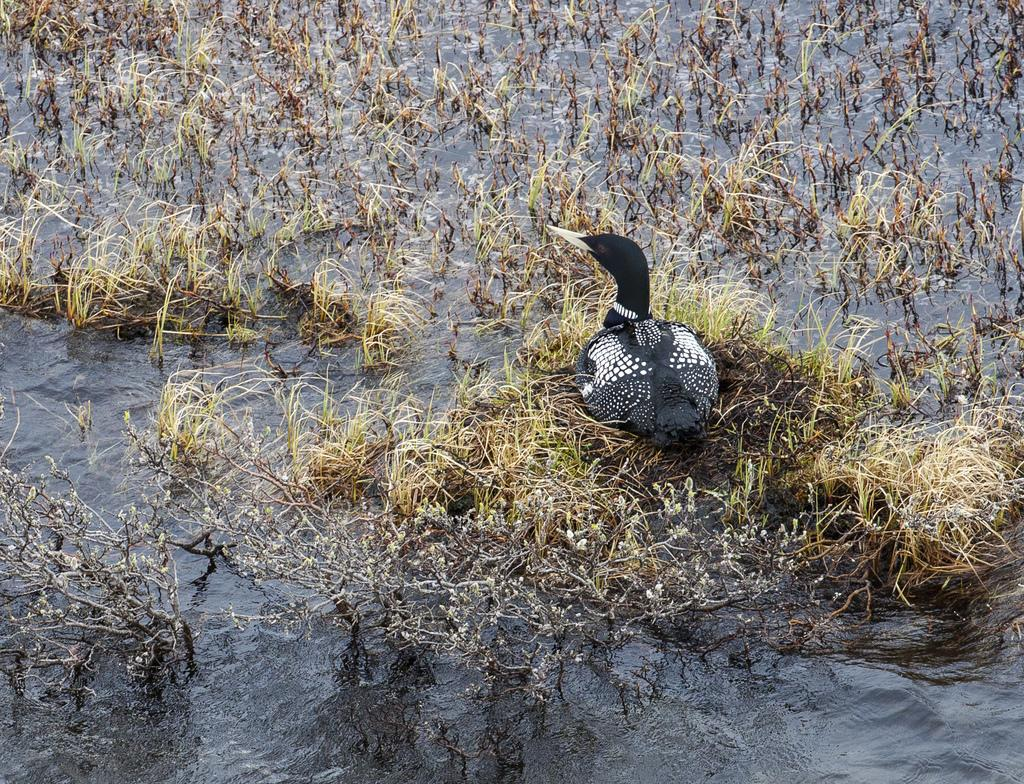What is the primary element in the image? There is water in the image. What can be found within the water? There are plants in the water. Is there any wildlife present in the image? Yes, there is a bird sitting on the plants or water. What type of tail can be seen on the plants in the image? There are no tails present in the image, as the plants and bird do not have tails. 